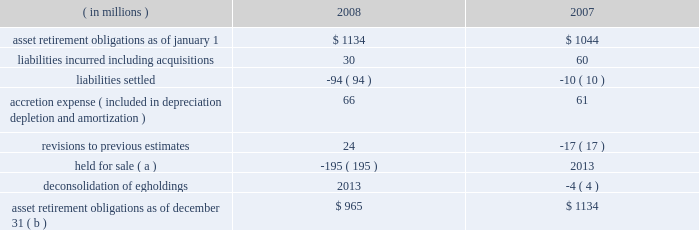Marathon oil corporation notes to consolidated financial statements ( f ) this sale-leaseback financing arrangement relates to a lease of a slab caster at united states steel 2019s fairfield works facility in alabama .
We are the primary obligor under this lease .
Under the financial matters agreement , united states steel has assumed responsibility for all obligations under this lease .
This lease is an amortizing financing with a final maturity of 2012 , subject to additional extensions .
( g ) this obligation relates to a lease of equipment at united states steel 2019s clairton works cokemaking facility in pennsylvania .
We are the primary obligor under this lease .
Under the financial matters agreement , united states steel has assumed responsibility for all obligations under this lease .
This lease is an amortizing financing with a final maturity of 2012 .
( h ) marathon oil canada corporation had an 805 million canadian dollar revolving term credit facility which was secured by substantially all of marathon oil canada corporation 2019s assets and included certain financial covenants , including leverage and interest coverage ratios .
In february 2008 , the outstanding balance was repaid and the facility was terminated .
( i ) these notes are senior secured notes of marathon oil canada corporation .
The notes were secured by substantially all of marathon oil canada corporation 2019s assets .
In january 2008 , we provided a full and unconditional guarantee covering the payment of all principal and interest due under the senior notes .
( j ) these obligations as of december 31 , 2008 include $ 126 million related to assets under construction at that date for which capital leases or sale-leaseback financings will commence upon completion of construction .
The amounts currently reported are based upon the percent of construction completed as of december 31 , 2008 and therefore do not reflect future minimum lease obligations of $ 209 million .
( k ) payments of long-term debt for the years 2009 2013 2013 are $ 99 million , $ 98 million , $ 257 million , $ 1487 million and $ 279 million .
Of these amounts , payments assumed by united states steel are $ 15 million , $ 17 million , $ 161 million , $ 19 million and zero .
( l ) in the event of a change in control , as defined in the related agreements , debt obligations totaling $ 669 million at december 31 , 2008 , may be declared immediately due and payable .
( m ) see note 17 for information on interest rate swaps .
On february 17 , 2009 , we issued $ 700 million aggregate principal amount of senior notes bearing interest at 6.5 percent with a maturity date of february 15 , 2014 and $ 800 million aggregate principal amount of senior notes bearing interest at 7.5 percent with a maturity date of february 15 , 2019 .
Interest on both issues is payable semi- annually beginning august 15 , 2009 .
21 .
Asset retirement obligations the following summarizes the changes in asset retirement obligations : ( in millions ) 2008 2007 .
Asset retirement obligations as of december 31 ( b ) $ 965 $ 1134 ( a ) see note 7 for information related to our assets held for sale .
( b ) includes asset retirement obligation of $ 2 and $ 3 million classified as short-term at december 31 , 2008 , and 2007. .
In millions , what was the total asset retirement obligations as of december 31 2007 and 2008? 
Computations: (965 + 1134)
Answer: 2099.0. 